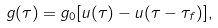Convert formula to latex. <formula><loc_0><loc_0><loc_500><loc_500>g ( \tau ) = g _ { 0 } [ u ( \tau ) - u ( \tau - \tau _ { f } ) ] ,</formula> 